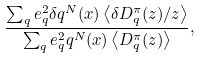Convert formula to latex. <formula><loc_0><loc_0><loc_500><loc_500>\frac { \sum _ { q } e ^ { 2 } _ { q } \delta q ^ { N } ( x ) \left < \delta D ^ { \pi } _ { q } ( z ) / z \right > } { \sum _ { q } e ^ { 2 } _ { q } q ^ { N } ( x ) \left < D ^ { \pi } _ { q } ( z ) \right > } ,</formula> 